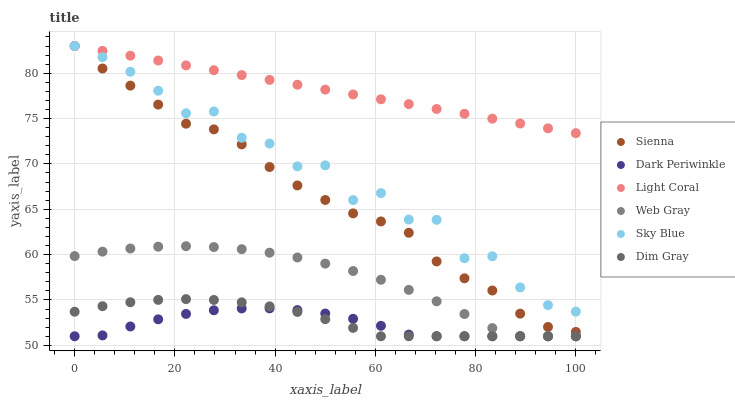Does Dark Periwinkle have the minimum area under the curve?
Answer yes or no. Yes. Does Light Coral have the maximum area under the curve?
Answer yes or no. Yes. Does Dim Gray have the minimum area under the curve?
Answer yes or no. No. Does Dim Gray have the maximum area under the curve?
Answer yes or no. No. Is Light Coral the smoothest?
Answer yes or no. Yes. Is Sky Blue the roughest?
Answer yes or no. Yes. Is Dim Gray the smoothest?
Answer yes or no. No. Is Dim Gray the roughest?
Answer yes or no. No. Does Dim Gray have the lowest value?
Answer yes or no. Yes. Does Sienna have the lowest value?
Answer yes or no. No. Does Sky Blue have the highest value?
Answer yes or no. Yes. Does Dim Gray have the highest value?
Answer yes or no. No. Is Dim Gray less than Sky Blue?
Answer yes or no. Yes. Is Light Coral greater than Web Gray?
Answer yes or no. Yes. Does Light Coral intersect Sienna?
Answer yes or no. Yes. Is Light Coral less than Sienna?
Answer yes or no. No. Is Light Coral greater than Sienna?
Answer yes or no. No. Does Dim Gray intersect Sky Blue?
Answer yes or no. No. 